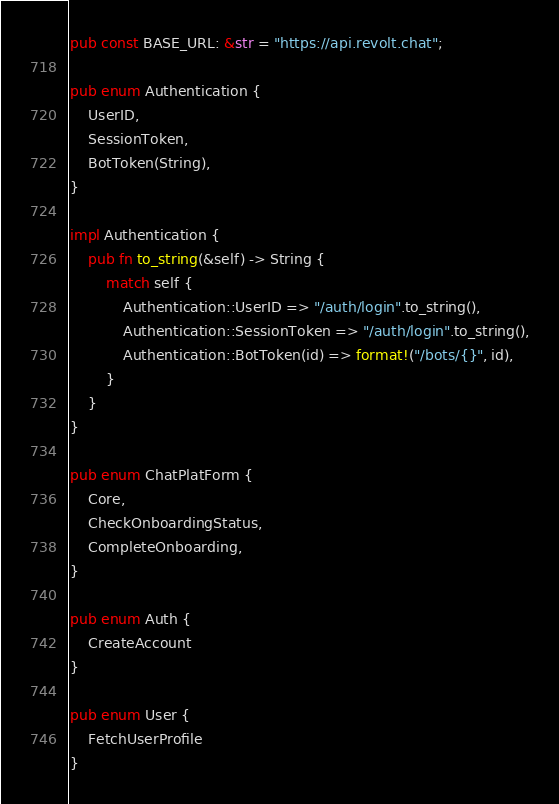<code> <loc_0><loc_0><loc_500><loc_500><_Rust_>
pub const BASE_URL: &str = "https://api.revolt.chat";

pub enum Authentication {
    UserID,
    SessionToken,
    BotToken(String),
}

impl Authentication {
    pub fn to_string(&self) -> String {
        match self {
            Authentication::UserID => "/auth/login".to_string(),
            Authentication::SessionToken => "/auth/login".to_string(),
            Authentication::BotToken(id) => format!("/bots/{}", id),
        }
    }
}

pub enum ChatPlatForm {
    Core,
    CheckOnboardingStatus,
    CompleteOnboarding,
}

pub enum Auth {
    CreateAccount
}

pub enum User {
    FetchUserProfile
}</code> 